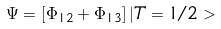Convert formula to latex. <formula><loc_0><loc_0><loc_500><loc_500>\Psi = [ \Phi _ { 1 2 } + \Phi _ { 1 3 } ] \, | T = 1 / 2 ></formula> 